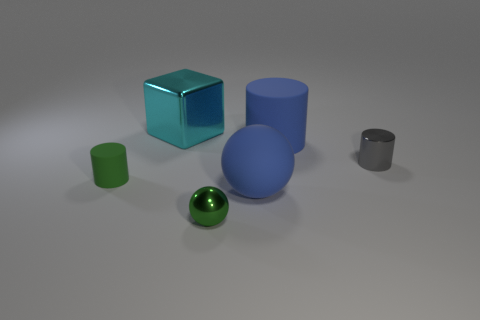Subtract all tiny cylinders. How many cylinders are left? 1 Add 1 big things. How many objects exist? 7 Subtract all green cylinders. How many cylinders are left? 2 Subtract all cubes. How many objects are left? 5 Subtract 1 cylinders. How many cylinders are left? 2 Subtract all gray cubes. Subtract all purple balls. How many cubes are left? 1 Subtract all green cylinders. How many gray balls are left? 0 Subtract all big matte cylinders. Subtract all big blue cylinders. How many objects are left? 4 Add 2 rubber spheres. How many rubber spheres are left? 3 Add 1 big shiny objects. How many big shiny objects exist? 2 